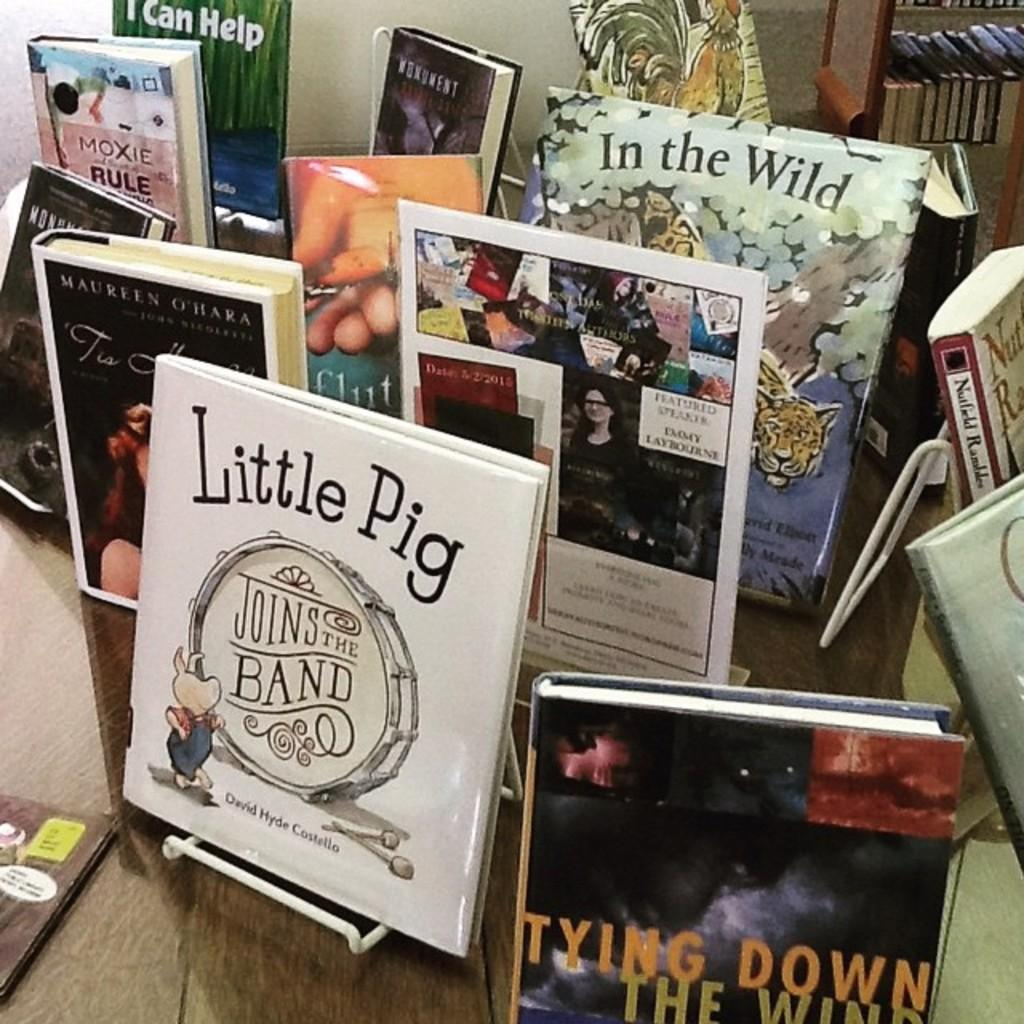<image>
Present a compact description of the photo's key features. The bookstore is selling a book titled "Little Pig Joins The Band". 